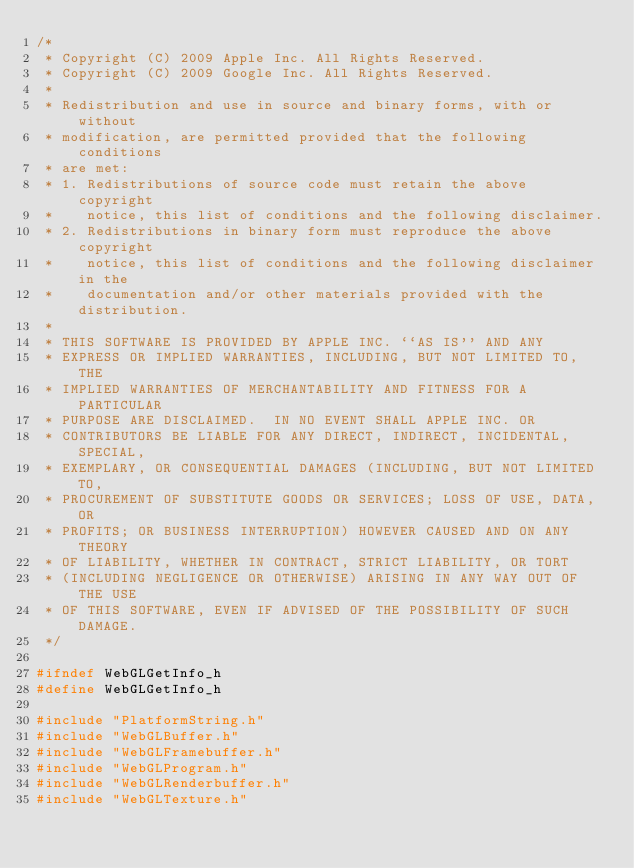Convert code to text. <code><loc_0><loc_0><loc_500><loc_500><_C_>/*
 * Copyright (C) 2009 Apple Inc. All Rights Reserved.
 * Copyright (C) 2009 Google Inc. All Rights Reserved.
 *
 * Redistribution and use in source and binary forms, with or without
 * modification, are permitted provided that the following conditions
 * are met:
 * 1. Redistributions of source code must retain the above copyright
 *    notice, this list of conditions and the following disclaimer.
 * 2. Redistributions in binary form must reproduce the above copyright
 *    notice, this list of conditions and the following disclaimer in the
 *    documentation and/or other materials provided with the distribution.
 *
 * THIS SOFTWARE IS PROVIDED BY APPLE INC. ``AS IS'' AND ANY
 * EXPRESS OR IMPLIED WARRANTIES, INCLUDING, BUT NOT LIMITED TO, THE
 * IMPLIED WARRANTIES OF MERCHANTABILITY AND FITNESS FOR A PARTICULAR
 * PURPOSE ARE DISCLAIMED.  IN NO EVENT SHALL APPLE INC. OR
 * CONTRIBUTORS BE LIABLE FOR ANY DIRECT, INDIRECT, INCIDENTAL, SPECIAL,
 * EXEMPLARY, OR CONSEQUENTIAL DAMAGES (INCLUDING, BUT NOT LIMITED TO,
 * PROCUREMENT OF SUBSTITUTE GOODS OR SERVICES; LOSS OF USE, DATA, OR
 * PROFITS; OR BUSINESS INTERRUPTION) HOWEVER CAUSED AND ON ANY THEORY
 * OF LIABILITY, WHETHER IN CONTRACT, STRICT LIABILITY, OR TORT
 * (INCLUDING NEGLIGENCE OR OTHERWISE) ARISING IN ANY WAY OUT OF THE USE
 * OF THIS SOFTWARE, EVEN IF ADVISED OF THE POSSIBILITY OF SUCH DAMAGE.
 */

#ifndef WebGLGetInfo_h
#define WebGLGetInfo_h

#include "PlatformString.h"
#include "WebGLBuffer.h"
#include "WebGLFramebuffer.h"
#include "WebGLProgram.h"
#include "WebGLRenderbuffer.h"
#include "WebGLTexture.h"</code> 